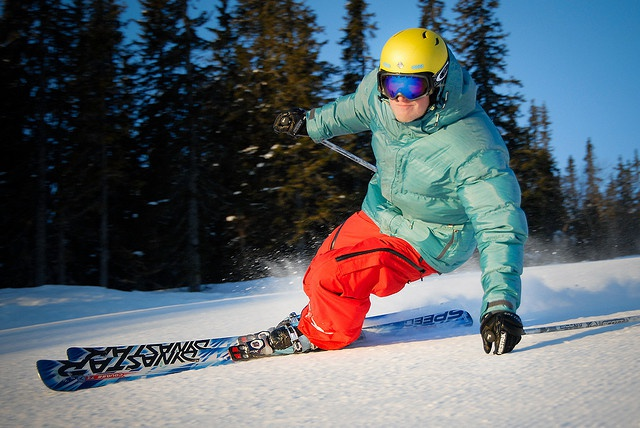Describe the objects in this image and their specific colors. I can see people in darkblue, teal, darkgray, and red tones and skis in darkblue, black, darkgray, gray, and navy tones in this image. 